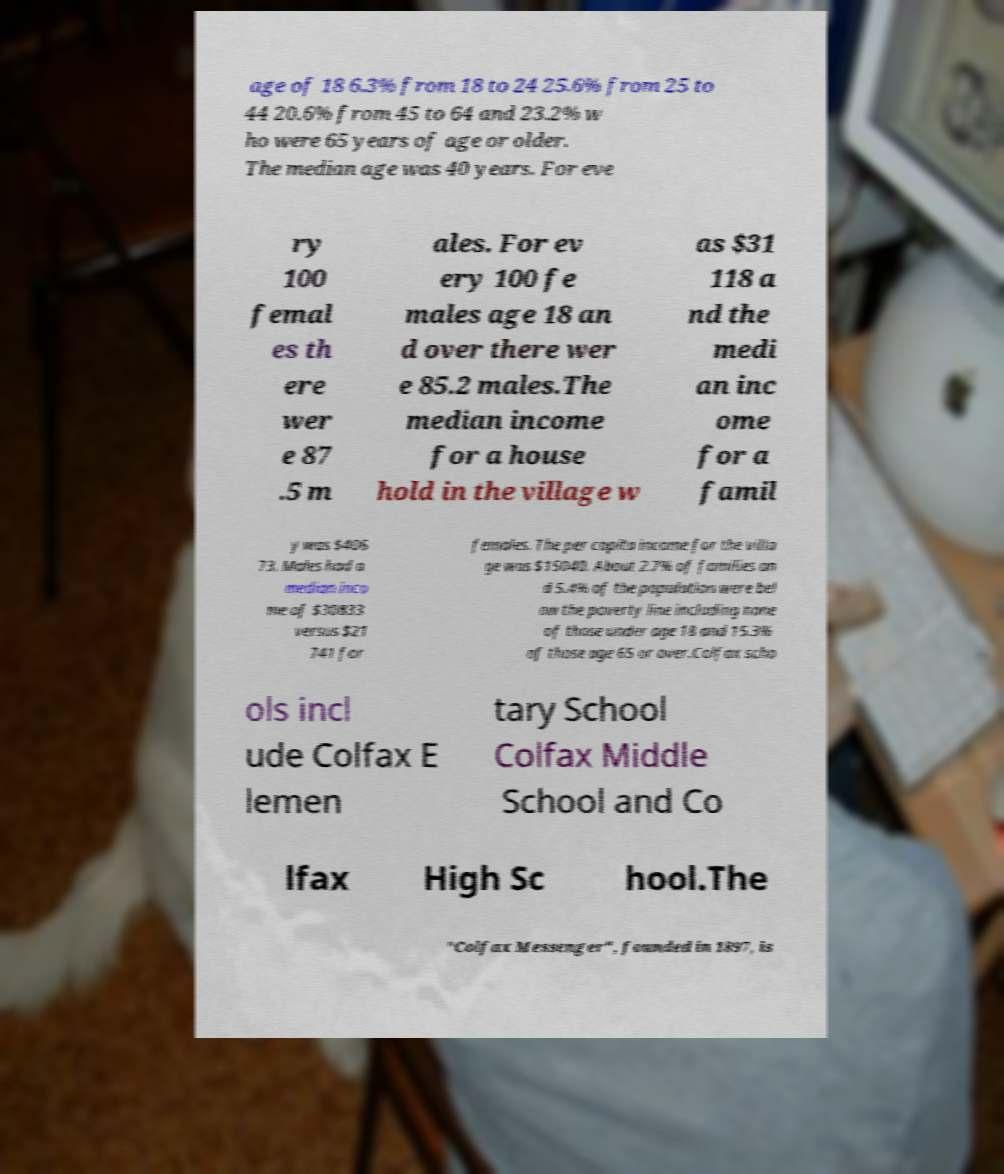There's text embedded in this image that I need extracted. Can you transcribe it verbatim? age of 18 6.3% from 18 to 24 25.6% from 25 to 44 20.6% from 45 to 64 and 23.2% w ho were 65 years of age or older. The median age was 40 years. For eve ry 100 femal es th ere wer e 87 .5 m ales. For ev ery 100 fe males age 18 an d over there wer e 85.2 males.The median income for a house hold in the village w as $31 118 a nd the medi an inc ome for a famil y was $406 73. Males had a median inco me of $30833 versus $21 741 for females. The per capita income for the villa ge was $15040. About 2.7% of families an d 5.4% of the population were bel ow the poverty line including none of those under age 18 and 15.3% of those age 65 or over.Colfax scho ols incl ude Colfax E lemen tary School Colfax Middle School and Co lfax High Sc hool.The "Colfax Messenger", founded in 1897, is 